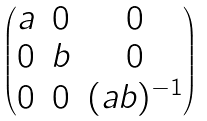<formula> <loc_0><loc_0><loc_500><loc_500>\begin{pmatrix} a & 0 & 0 \\ 0 & b & 0 \\ 0 & 0 & ( a b ) ^ { - 1 } \end{pmatrix}</formula> 